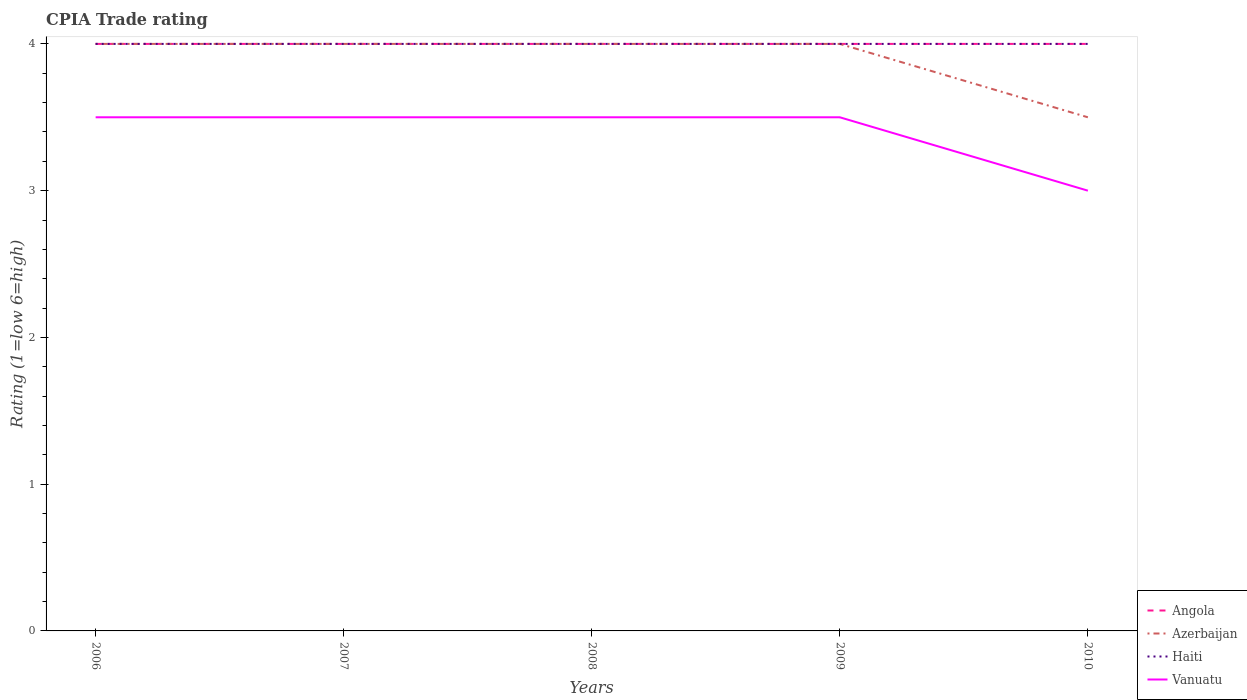How many different coloured lines are there?
Give a very brief answer. 4. Across all years, what is the maximum CPIA rating in Vanuatu?
Your response must be concise. 3. In which year was the CPIA rating in Haiti maximum?
Provide a short and direct response. 2006. What is the total CPIA rating in Haiti in the graph?
Give a very brief answer. 0. What is the difference between the highest and the second highest CPIA rating in Azerbaijan?
Make the answer very short. 0.5. Is the CPIA rating in Haiti strictly greater than the CPIA rating in Vanuatu over the years?
Ensure brevity in your answer.  No. How many lines are there?
Offer a very short reply. 4. Are the values on the major ticks of Y-axis written in scientific E-notation?
Your response must be concise. No. Does the graph contain any zero values?
Your answer should be compact. No. Does the graph contain grids?
Your answer should be very brief. No. How are the legend labels stacked?
Keep it short and to the point. Vertical. What is the title of the graph?
Provide a short and direct response. CPIA Trade rating. Does "Congo (Democratic)" appear as one of the legend labels in the graph?
Give a very brief answer. No. What is the label or title of the Y-axis?
Provide a short and direct response. Rating (1=low 6=high). What is the Rating (1=low 6=high) of Angola in 2006?
Make the answer very short. 4. What is the Rating (1=low 6=high) in Azerbaijan in 2006?
Offer a terse response. 4. What is the Rating (1=low 6=high) of Vanuatu in 2006?
Ensure brevity in your answer.  3.5. What is the Rating (1=low 6=high) in Angola in 2007?
Offer a terse response. 4. What is the Rating (1=low 6=high) in Azerbaijan in 2007?
Your response must be concise. 4. What is the Rating (1=low 6=high) of Haiti in 2007?
Provide a short and direct response. 4. What is the Rating (1=low 6=high) in Azerbaijan in 2008?
Your answer should be very brief. 4. What is the Rating (1=low 6=high) in Vanuatu in 2008?
Provide a succinct answer. 3.5. What is the Rating (1=low 6=high) of Vanuatu in 2009?
Keep it short and to the point. 3.5. What is the Rating (1=low 6=high) in Angola in 2010?
Provide a short and direct response. 4. What is the Rating (1=low 6=high) of Haiti in 2010?
Make the answer very short. 4. What is the Rating (1=low 6=high) in Vanuatu in 2010?
Give a very brief answer. 3. Across all years, what is the maximum Rating (1=low 6=high) in Angola?
Keep it short and to the point. 4. Across all years, what is the maximum Rating (1=low 6=high) in Azerbaijan?
Make the answer very short. 4. Across all years, what is the maximum Rating (1=low 6=high) in Haiti?
Give a very brief answer. 4. Across all years, what is the maximum Rating (1=low 6=high) in Vanuatu?
Ensure brevity in your answer.  3.5. What is the total Rating (1=low 6=high) in Angola in the graph?
Your answer should be compact. 20. What is the total Rating (1=low 6=high) in Haiti in the graph?
Make the answer very short. 20. What is the difference between the Rating (1=low 6=high) in Angola in 2006 and that in 2007?
Provide a short and direct response. 0. What is the difference between the Rating (1=low 6=high) of Haiti in 2006 and that in 2007?
Ensure brevity in your answer.  0. What is the difference between the Rating (1=low 6=high) of Azerbaijan in 2006 and that in 2008?
Ensure brevity in your answer.  0. What is the difference between the Rating (1=low 6=high) in Haiti in 2006 and that in 2008?
Offer a very short reply. 0. What is the difference between the Rating (1=low 6=high) of Angola in 2006 and that in 2009?
Your response must be concise. 0. What is the difference between the Rating (1=low 6=high) in Azerbaijan in 2006 and that in 2009?
Offer a very short reply. 0. What is the difference between the Rating (1=low 6=high) in Haiti in 2006 and that in 2009?
Provide a succinct answer. 0. What is the difference between the Rating (1=low 6=high) of Angola in 2006 and that in 2010?
Ensure brevity in your answer.  0. What is the difference between the Rating (1=low 6=high) of Haiti in 2006 and that in 2010?
Your answer should be compact. 0. What is the difference between the Rating (1=low 6=high) of Vanuatu in 2007 and that in 2008?
Provide a short and direct response. 0. What is the difference between the Rating (1=low 6=high) of Haiti in 2007 and that in 2009?
Make the answer very short. 0. What is the difference between the Rating (1=low 6=high) in Vanuatu in 2007 and that in 2009?
Offer a terse response. 0. What is the difference between the Rating (1=low 6=high) of Angola in 2007 and that in 2010?
Offer a very short reply. 0. What is the difference between the Rating (1=low 6=high) in Azerbaijan in 2008 and that in 2009?
Give a very brief answer. 0. What is the difference between the Rating (1=low 6=high) in Haiti in 2008 and that in 2010?
Give a very brief answer. 0. What is the difference between the Rating (1=low 6=high) of Haiti in 2009 and that in 2010?
Your answer should be very brief. 0. What is the difference between the Rating (1=low 6=high) of Vanuatu in 2009 and that in 2010?
Your answer should be compact. 0.5. What is the difference between the Rating (1=low 6=high) in Haiti in 2006 and the Rating (1=low 6=high) in Vanuatu in 2007?
Offer a very short reply. 0.5. What is the difference between the Rating (1=low 6=high) of Angola in 2006 and the Rating (1=low 6=high) of Azerbaijan in 2008?
Offer a terse response. 0. What is the difference between the Rating (1=low 6=high) in Angola in 2006 and the Rating (1=low 6=high) in Haiti in 2008?
Offer a terse response. 0. What is the difference between the Rating (1=low 6=high) in Angola in 2006 and the Rating (1=low 6=high) in Vanuatu in 2008?
Your answer should be compact. 0.5. What is the difference between the Rating (1=low 6=high) of Azerbaijan in 2006 and the Rating (1=low 6=high) of Haiti in 2008?
Ensure brevity in your answer.  0. What is the difference between the Rating (1=low 6=high) of Angola in 2006 and the Rating (1=low 6=high) of Haiti in 2009?
Make the answer very short. 0. What is the difference between the Rating (1=low 6=high) in Azerbaijan in 2006 and the Rating (1=low 6=high) in Haiti in 2009?
Offer a very short reply. 0. What is the difference between the Rating (1=low 6=high) in Azerbaijan in 2006 and the Rating (1=low 6=high) in Vanuatu in 2009?
Provide a succinct answer. 0.5. What is the difference between the Rating (1=low 6=high) in Haiti in 2006 and the Rating (1=low 6=high) in Vanuatu in 2009?
Offer a terse response. 0.5. What is the difference between the Rating (1=low 6=high) of Angola in 2006 and the Rating (1=low 6=high) of Haiti in 2010?
Provide a succinct answer. 0. What is the difference between the Rating (1=low 6=high) of Angola in 2006 and the Rating (1=low 6=high) of Vanuatu in 2010?
Offer a very short reply. 1. What is the difference between the Rating (1=low 6=high) of Azerbaijan in 2006 and the Rating (1=low 6=high) of Haiti in 2010?
Keep it short and to the point. 0. What is the difference between the Rating (1=low 6=high) of Azerbaijan in 2006 and the Rating (1=low 6=high) of Vanuatu in 2010?
Your answer should be very brief. 1. What is the difference between the Rating (1=low 6=high) in Haiti in 2006 and the Rating (1=low 6=high) in Vanuatu in 2010?
Make the answer very short. 1. What is the difference between the Rating (1=low 6=high) in Angola in 2007 and the Rating (1=low 6=high) in Azerbaijan in 2008?
Provide a succinct answer. 0. What is the difference between the Rating (1=low 6=high) in Angola in 2007 and the Rating (1=low 6=high) in Haiti in 2008?
Your response must be concise. 0. What is the difference between the Rating (1=low 6=high) of Angola in 2007 and the Rating (1=low 6=high) of Haiti in 2009?
Ensure brevity in your answer.  0. What is the difference between the Rating (1=low 6=high) in Angola in 2007 and the Rating (1=low 6=high) in Vanuatu in 2009?
Make the answer very short. 0.5. What is the difference between the Rating (1=low 6=high) of Azerbaijan in 2007 and the Rating (1=low 6=high) of Haiti in 2009?
Your answer should be compact. 0. What is the difference between the Rating (1=low 6=high) in Azerbaijan in 2007 and the Rating (1=low 6=high) in Vanuatu in 2009?
Ensure brevity in your answer.  0.5. What is the difference between the Rating (1=low 6=high) in Haiti in 2007 and the Rating (1=low 6=high) in Vanuatu in 2009?
Offer a very short reply. 0.5. What is the difference between the Rating (1=low 6=high) in Angola in 2007 and the Rating (1=low 6=high) in Azerbaijan in 2010?
Your response must be concise. 0.5. What is the difference between the Rating (1=low 6=high) in Azerbaijan in 2007 and the Rating (1=low 6=high) in Haiti in 2010?
Make the answer very short. 0. What is the difference between the Rating (1=low 6=high) in Azerbaijan in 2007 and the Rating (1=low 6=high) in Vanuatu in 2010?
Ensure brevity in your answer.  1. What is the difference between the Rating (1=low 6=high) in Angola in 2008 and the Rating (1=low 6=high) in Haiti in 2009?
Offer a terse response. 0. What is the difference between the Rating (1=low 6=high) of Angola in 2008 and the Rating (1=low 6=high) of Azerbaijan in 2010?
Your answer should be very brief. 0.5. What is the difference between the Rating (1=low 6=high) in Angola in 2008 and the Rating (1=low 6=high) in Vanuatu in 2010?
Offer a terse response. 1. What is the difference between the Rating (1=low 6=high) in Azerbaijan in 2008 and the Rating (1=low 6=high) in Haiti in 2010?
Offer a terse response. 0. What is the difference between the Rating (1=low 6=high) in Haiti in 2008 and the Rating (1=low 6=high) in Vanuatu in 2010?
Your answer should be very brief. 1. What is the difference between the Rating (1=low 6=high) of Angola in 2009 and the Rating (1=low 6=high) of Azerbaijan in 2010?
Your answer should be compact. 0.5. What is the difference between the Rating (1=low 6=high) in Angola in 2009 and the Rating (1=low 6=high) in Vanuatu in 2010?
Ensure brevity in your answer.  1. What is the average Rating (1=low 6=high) in Haiti per year?
Your answer should be compact. 4. In the year 2006, what is the difference between the Rating (1=low 6=high) of Angola and Rating (1=low 6=high) of Haiti?
Offer a terse response. 0. In the year 2006, what is the difference between the Rating (1=low 6=high) of Azerbaijan and Rating (1=low 6=high) of Vanuatu?
Your answer should be very brief. 0.5. In the year 2006, what is the difference between the Rating (1=low 6=high) of Haiti and Rating (1=low 6=high) of Vanuatu?
Offer a very short reply. 0.5. In the year 2007, what is the difference between the Rating (1=low 6=high) in Angola and Rating (1=low 6=high) in Haiti?
Provide a succinct answer. 0. In the year 2007, what is the difference between the Rating (1=low 6=high) of Azerbaijan and Rating (1=low 6=high) of Haiti?
Make the answer very short. 0. In the year 2007, what is the difference between the Rating (1=low 6=high) of Azerbaijan and Rating (1=low 6=high) of Vanuatu?
Make the answer very short. 0.5. In the year 2007, what is the difference between the Rating (1=low 6=high) of Haiti and Rating (1=low 6=high) of Vanuatu?
Provide a succinct answer. 0.5. In the year 2009, what is the difference between the Rating (1=low 6=high) in Azerbaijan and Rating (1=low 6=high) in Vanuatu?
Your answer should be very brief. 0.5. In the year 2010, what is the difference between the Rating (1=low 6=high) of Angola and Rating (1=low 6=high) of Haiti?
Your answer should be very brief. 0. In the year 2010, what is the difference between the Rating (1=low 6=high) in Azerbaijan and Rating (1=low 6=high) in Haiti?
Offer a very short reply. -0.5. In the year 2010, what is the difference between the Rating (1=low 6=high) in Azerbaijan and Rating (1=low 6=high) in Vanuatu?
Offer a very short reply. 0.5. What is the ratio of the Rating (1=low 6=high) of Angola in 2006 to that in 2007?
Your answer should be compact. 1. What is the ratio of the Rating (1=low 6=high) in Azerbaijan in 2006 to that in 2007?
Keep it short and to the point. 1. What is the ratio of the Rating (1=low 6=high) in Haiti in 2006 to that in 2007?
Your response must be concise. 1. What is the ratio of the Rating (1=low 6=high) of Vanuatu in 2006 to that in 2007?
Offer a terse response. 1. What is the ratio of the Rating (1=low 6=high) in Angola in 2006 to that in 2008?
Make the answer very short. 1. What is the ratio of the Rating (1=low 6=high) in Azerbaijan in 2006 to that in 2008?
Your answer should be very brief. 1. What is the ratio of the Rating (1=low 6=high) in Haiti in 2006 to that in 2009?
Make the answer very short. 1. What is the ratio of the Rating (1=low 6=high) in Vanuatu in 2006 to that in 2009?
Your answer should be compact. 1. What is the ratio of the Rating (1=low 6=high) of Angola in 2007 to that in 2008?
Keep it short and to the point. 1. What is the ratio of the Rating (1=low 6=high) in Haiti in 2007 to that in 2008?
Your answer should be compact. 1. What is the ratio of the Rating (1=low 6=high) of Vanuatu in 2007 to that in 2008?
Give a very brief answer. 1. What is the ratio of the Rating (1=low 6=high) in Haiti in 2007 to that in 2009?
Keep it short and to the point. 1. What is the ratio of the Rating (1=low 6=high) in Azerbaijan in 2007 to that in 2010?
Your answer should be compact. 1.14. What is the ratio of the Rating (1=low 6=high) in Haiti in 2007 to that in 2010?
Offer a terse response. 1. What is the ratio of the Rating (1=low 6=high) in Vanuatu in 2008 to that in 2009?
Ensure brevity in your answer.  1. What is the ratio of the Rating (1=low 6=high) of Angola in 2008 to that in 2010?
Offer a terse response. 1. What is the ratio of the Rating (1=low 6=high) in Azerbaijan in 2008 to that in 2010?
Make the answer very short. 1.14. What is the ratio of the Rating (1=low 6=high) in Angola in 2009 to that in 2010?
Ensure brevity in your answer.  1. What is the ratio of the Rating (1=low 6=high) of Azerbaijan in 2009 to that in 2010?
Your answer should be compact. 1.14. What is the ratio of the Rating (1=low 6=high) in Haiti in 2009 to that in 2010?
Give a very brief answer. 1. What is the ratio of the Rating (1=low 6=high) in Vanuatu in 2009 to that in 2010?
Offer a very short reply. 1.17. What is the difference between the highest and the second highest Rating (1=low 6=high) in Angola?
Keep it short and to the point. 0. What is the difference between the highest and the second highest Rating (1=low 6=high) of Haiti?
Provide a succinct answer. 0. What is the difference between the highest and the lowest Rating (1=low 6=high) of Haiti?
Ensure brevity in your answer.  0. What is the difference between the highest and the lowest Rating (1=low 6=high) in Vanuatu?
Provide a succinct answer. 0.5. 